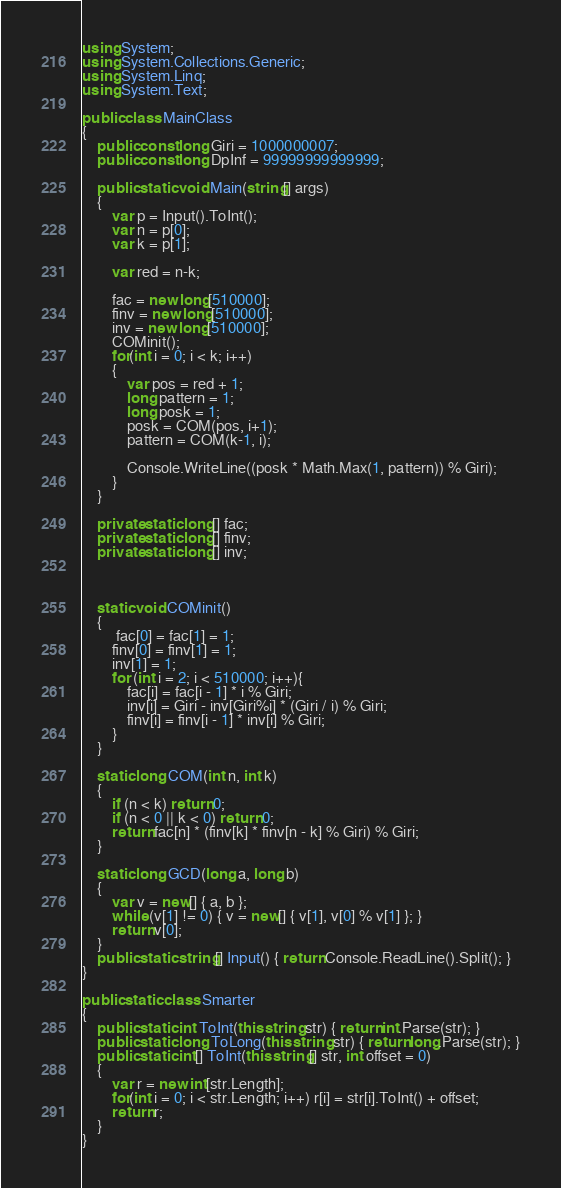<code> <loc_0><loc_0><loc_500><loc_500><_C#_>using System;
using System.Collections.Generic;
using System.Linq;
using System.Text;

public class MainClass
{
	public const long Giri = 1000000007;
	public const long DpInf = 99999999999999;
	
	public static void Main(string[] args)
	{
		var p = Input().ToInt();
		var n = p[0];
		var k = p[1];
		
		var red = n-k;
		
		fac = new long[510000];
		finv = new long[510000];
		inv = new long[510000];
		COMinit();
		for(int i = 0; i < k; i++)
		{
			var pos = red + 1;
			long pattern = 1;
			long posk = 1;
			posk = COM(pos, i+1);
			pattern = COM(k-1, i);
			
			Console.WriteLine((posk * Math.Max(1, pattern)) % Giri);
		}
	}

	private static long[] fac;
	private static long[] finv;
	private static long[] inv;
	

	
	static void COMinit()
	{
		 fac[0] = fac[1] = 1;
	    finv[0] = finv[1] = 1;
	    inv[1] = 1;
	    for (int i = 2; i < 510000; i++){
	        fac[i] = fac[i - 1] * i % Giri;
	        inv[i] = Giri - inv[Giri%i] * (Giri / i) % Giri;
	        finv[i] = finv[i - 1] * inv[i] % Giri;
	    }
	}
	
	static long COM(int n, int k)
	{
	    if (n < k) return 0;
	    if (n < 0 || k < 0) return 0;
	    return fac[n] * (finv[k] * finv[n - k] % Giri) % Giri;
	}
	
	static long GCD(long a, long b)
	{
		var v = new[] { a, b };
		while (v[1] != 0) { v = new[] { v[1], v[0] % v[1] }; }
		return v[0];
	}
	public static string[] Input() { return Console.ReadLine().Split(); }
}

public static class Smarter
{
	public static int ToInt(this string str) { return int.Parse(str); }
	public static long ToLong(this string str) { return long.Parse(str); }
	public static int[] ToInt(this string[] str, int offset = 0)
	{
		var r = new int[str.Length];
		for(int i = 0; i < str.Length; i++) r[i] = str[i].ToInt() + offset;
		return r;
	}
}</code> 